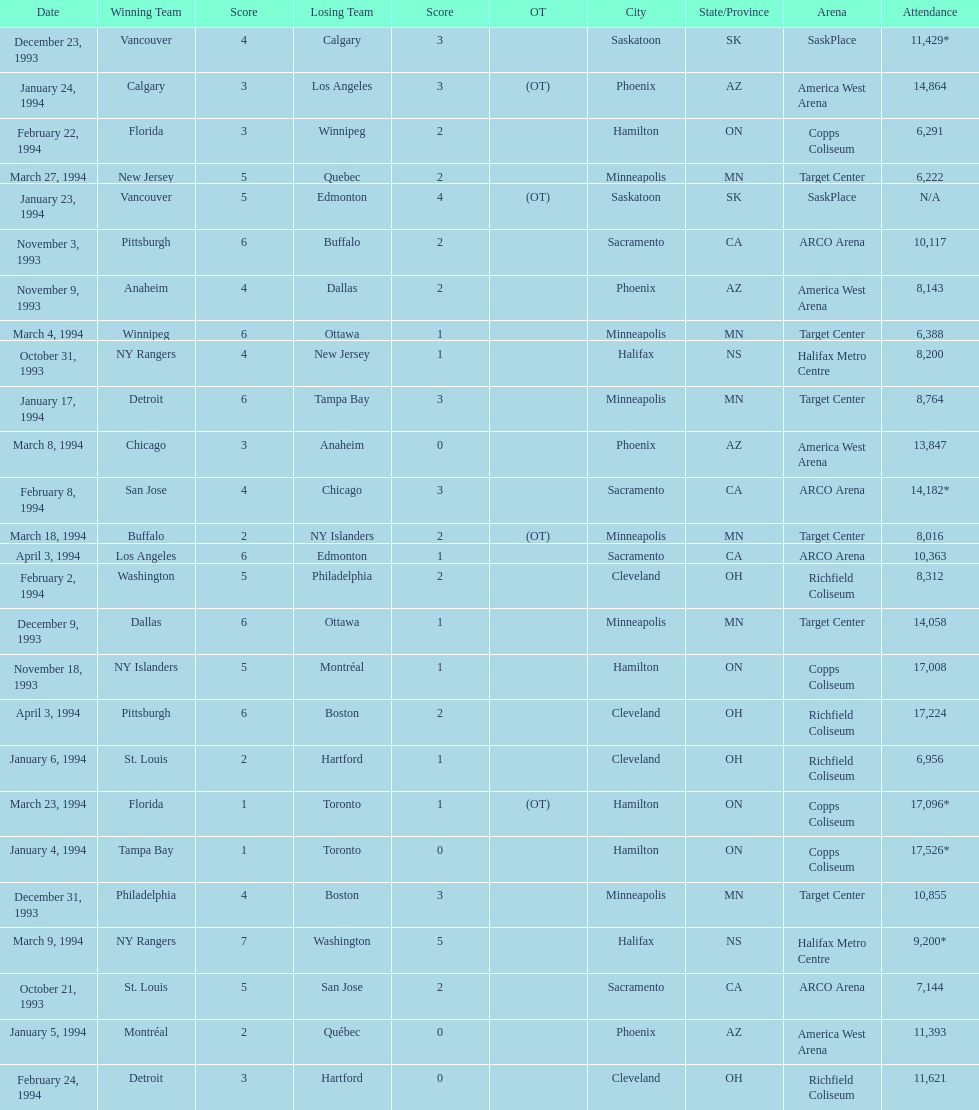When were the games played? October 21, 1993, October 31, 1993, November 3, 1993, November 9, 1993, November 18, 1993, December 9, 1993, December 23, 1993, December 31, 1993, January 4, 1994, January 5, 1994, January 6, 1994, January 17, 1994, January 23, 1994, January 24, 1994, February 2, 1994, February 8, 1994, February 22, 1994, February 24, 1994, March 4, 1994, March 8, 1994, March 9, 1994, March 18, 1994, March 23, 1994, March 27, 1994, April 3, 1994, April 3, 1994. What was the attendance for those games? 7,144, 8,200, 10,117, 8,143, 17,008, 14,058, 11,429*, 10,855, 17,526*, 11,393, 6,956, 8,764, N/A, 14,864, 8,312, 14,182*, 6,291, 11,621, 6,388, 13,847, 9,200*, 8,016, 17,096*, 6,222, 17,224, 10,363. Which date had the highest attendance? January 4, 1994. 